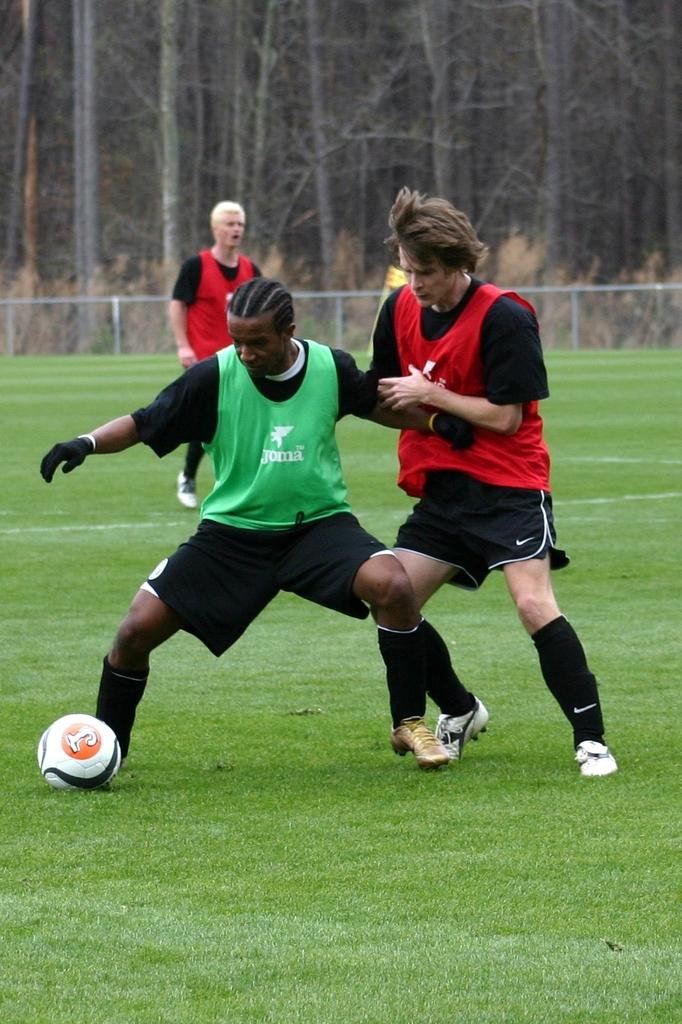What are the two men in the foreground of the image doing? The two men in the foreground of the image are playing football. What is happening in the background of the image? There is a man walking on the grass in the background of the image. What type of architectural feature can be seen in the background? Fencing is present in the background of the image. What type of natural elements are visible in the background? Trees are visible in the background of the image. Can you see a plane flying in the sky in the image? There is no plane visible in the image; it only shows two men playing football, a man walking on the grass, fencing, and trees in the background. Is there a pot being used by the men playing football in the image? There is no pot present in the image; the men are playing football with a ball. 